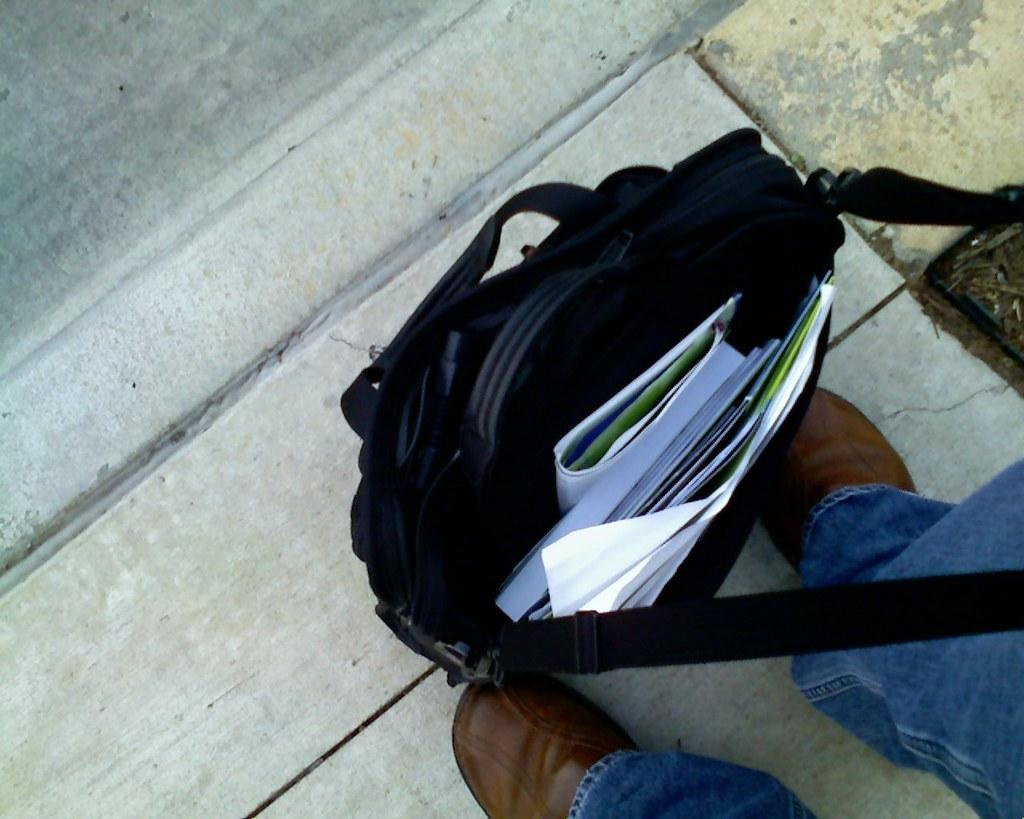What can be seen at the bottom of the image? There are legs with footwear visible in the image. What object is present in the image besides the legs? There is a bag in the image. What is inside the bag? The bag contains papers. Where is the bag located in the image? The bag is on the ground. What type of fuel is being used to power the peace in the image? There is no reference to peace or fuel in the image, so it is not possible to answer that question. 